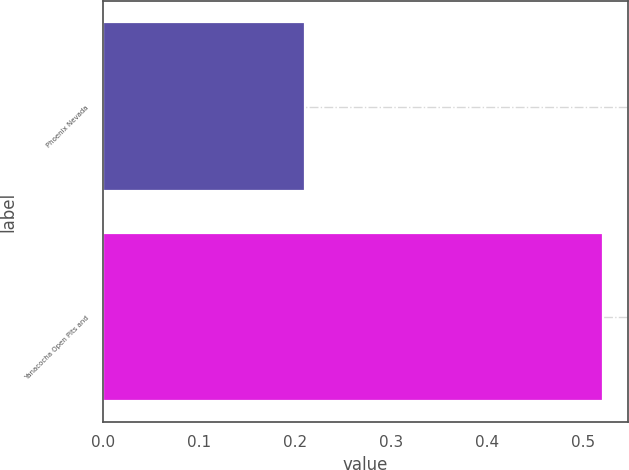Convert chart to OTSL. <chart><loc_0><loc_0><loc_500><loc_500><bar_chart><fcel>Phoenix Nevada<fcel>Yanacocha Open Pits and<nl><fcel>0.21<fcel>0.52<nl></chart> 